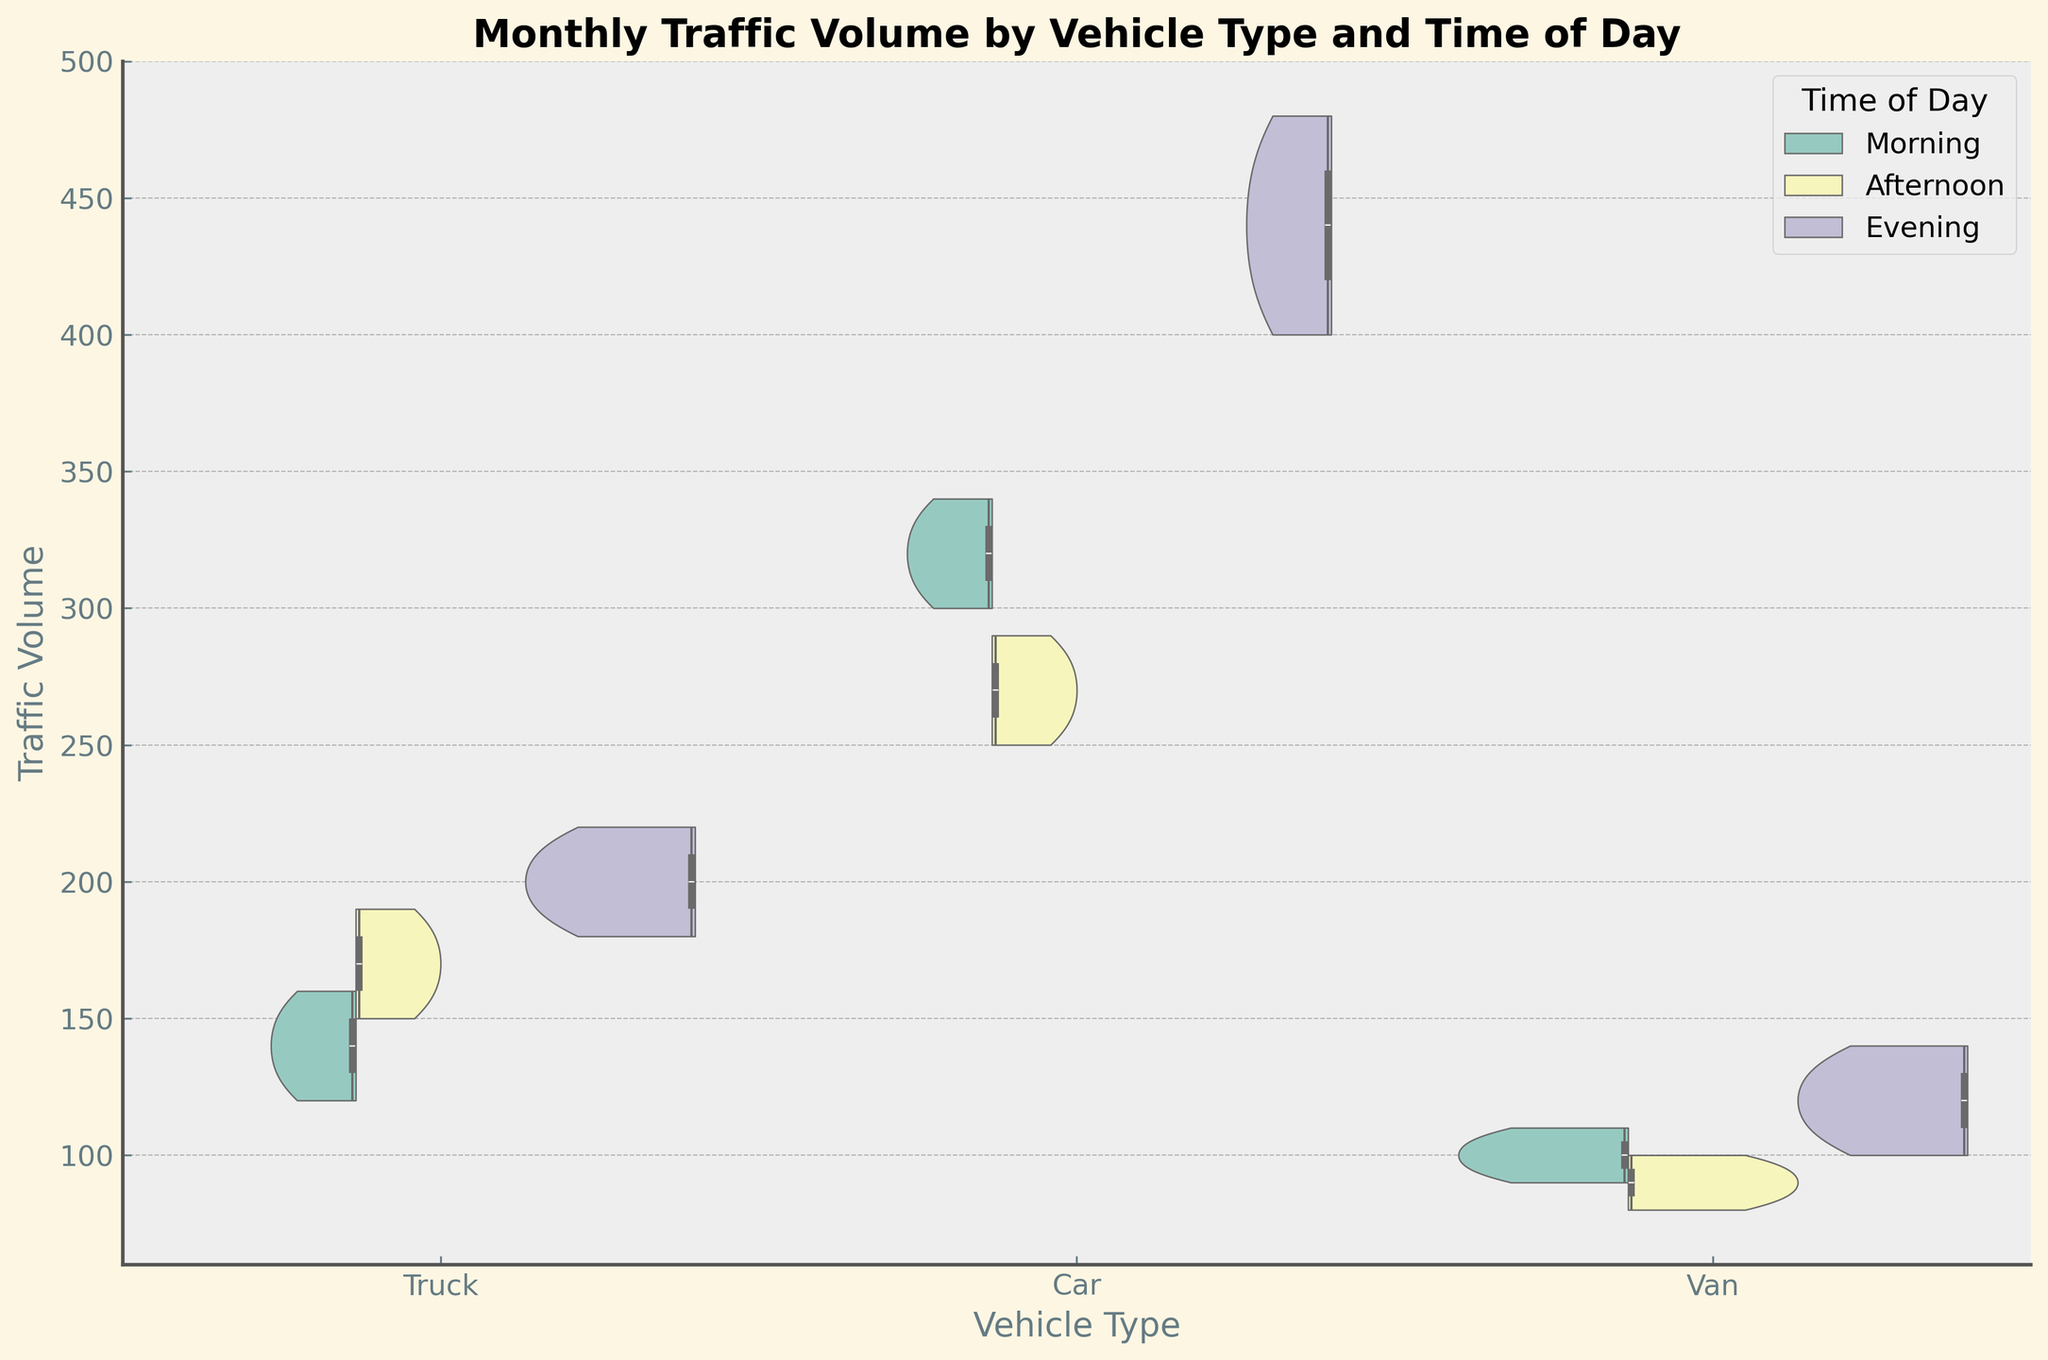What is the title of the figure? The title is usually the largest text at the top of the figure that summarises what the graph is about. It is often emphasized with a bold font to catch the viewer's attention.
Answer: Monthly Traffic Volume by Vehicle Type and Time of Day Which vehicle type has the lowest traffic volume in the morning? By observing the sections of the violin plot corresponding to the morning time, the data for the 'Van' is generally located at a lower traffic volume compared to 'Car' and 'Truck'.
Answer: Van What is the median traffic volume for cars in the evening? Locate the evening section of the plot for cars. The box inside the violin plot shows the median line within the shaded area. This line for cars during the evening is around 460.
Answer: 460 Which time of day has the highest traffic volume for trucks? Compare the three sections (Morning, Afternoon, Evening) of the violin plots for trucks. The evening section reaches higher traffic volumes compared to morning and afternoon.
Answer: Evening Is the variance in traffic volume for cars higher in the evening compared to the morning? Variance can be inferred from the width and spread of the violin plot. For cars, the violin plot for the evening is wider and more spread out compared to the morning, indicating higher variance.
Answer: Yes Which vehicle type shows the most consistent traffic volume across different times of the day? Consistency can be inferred by observing the width of the violin plots across different times of the day. The narrower the violins are, the more consistent the data. Vans show more consistent traffic volumes compared to cars and trucks.
Answer: Van By comparing trucks' median traffic volume in the morning and afternoon, which is higher? The median is depicted by the horizontal line inside the box part of the violin plot. The morning median for trucks is lower than the afternoon median.
Answer: Afternoon Does the traffic volume for any vehicle type overlap significantly across different times of day? Significant overlap can be observed in violin plots where the shapes of different times of day for the same vehicle type merge or are very close to each other. Cars show notable overlap between afternoon and evening.
Answer: Yes How does the peak traffic volume for vans compare between afternoon and evening? Peaks can be identified by the highest points of the violin plots. For vans, the peak in the evening reaches higher traffic volumes compared to the afternoon.
Answer: Evening What is the approximate interquartile range (IQR) for trucks in the afternoon? IQR can be determined by the distance between the top and bottom edges of the box plot inside the violin. For trucks in the afternoon, the IQR appears to range between 170 and 210. So, approximately 210 - 170 = 40.
Answer: 40 